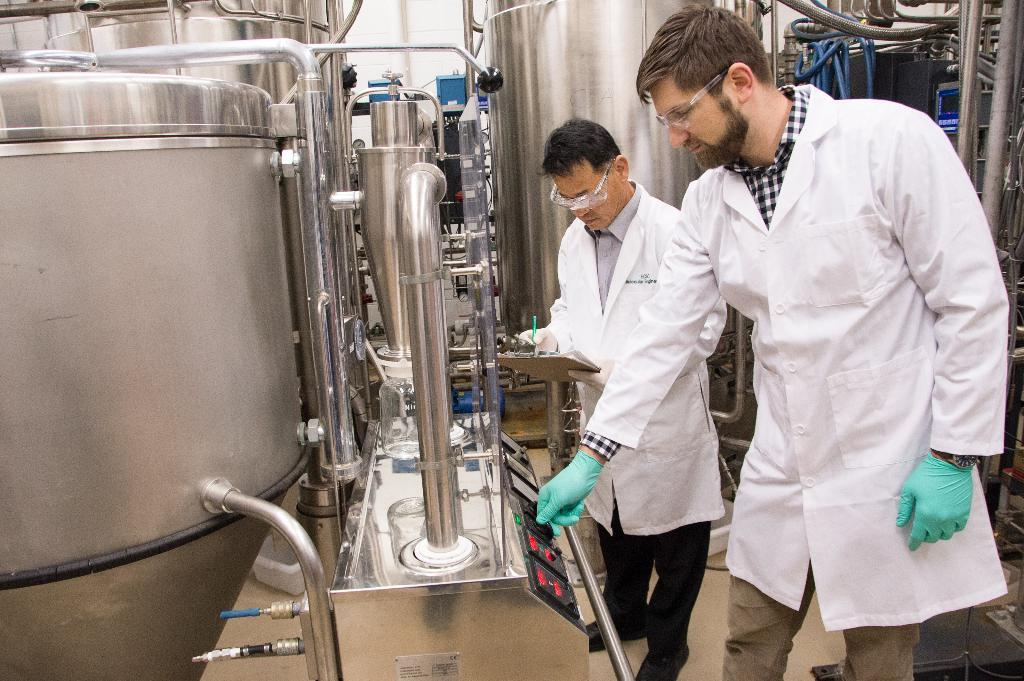What type of tanks are visible in the image? There are steel tanks in the image. What other objects can be seen in the image? There are pipes and a regulator in the image. What is the position of the regulator in the image? The regulator is at the bottom of the image. How many people are present in the image? There are two persons standing in the image. What are the persons wearing? The persons are wearing clothes. What type of lumber is being used to support the tanks in the image? There is no lumber present in the image; the tanks are made of steel and supported by pipes and a regulator. Is there a canvas covering the tanks in the image? There is no canvas present in the image; the tanks are visible and not covered. 